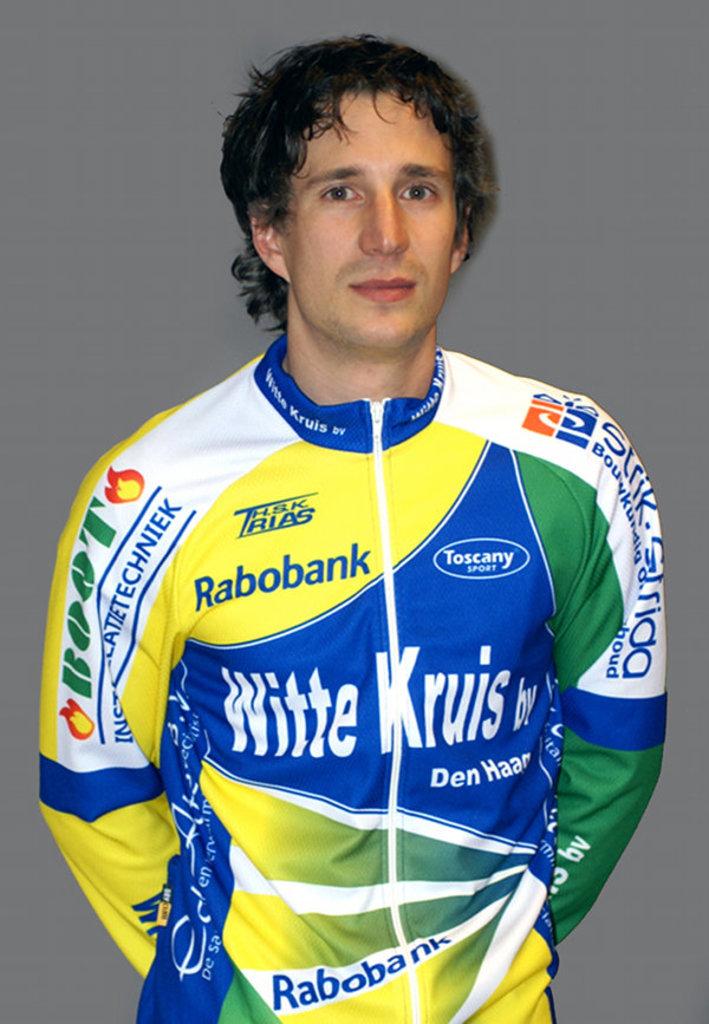Who is a sponsor for this person?
Your response must be concise. Rabobank. 